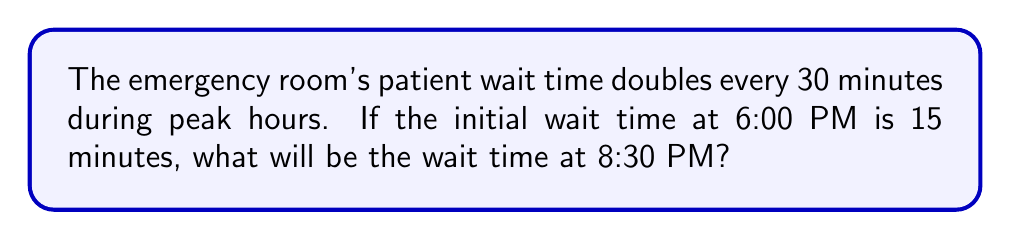Can you answer this question? Let's approach this step-by-step:

1) First, we need to determine how many 30-minute intervals are between 6:00 PM and 8:30 PM.
   - From 6:00 PM to 8:30 PM is 2.5 hours or 150 minutes.
   - This equals 5 intervals of 30 minutes each.

2) We can represent this situation using an exponential function:
   $$ W = 15 \cdot 2^n $$
   Where $W$ is the wait time and $n$ is the number of 30-minute intervals.

3) We know $n = 5$, so let's substitute this into our equation:
   $$ W = 15 \cdot 2^5 $$

4) Now, let's calculate $2^5$:
   $$ 2^5 = 2 \cdot 2 \cdot 2 \cdot 2 \cdot 2 = 32 $$

5) Substituting this back into our equation:
   $$ W = 15 \cdot 32 = 480 $$

Therefore, the wait time at 8:30 PM will be 480 minutes.
Answer: 480 minutes 